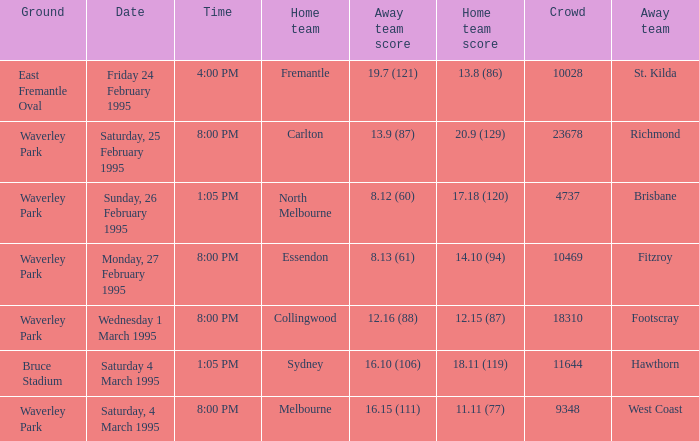Name the time for saturday 4 march 1995 1:05 PM. 